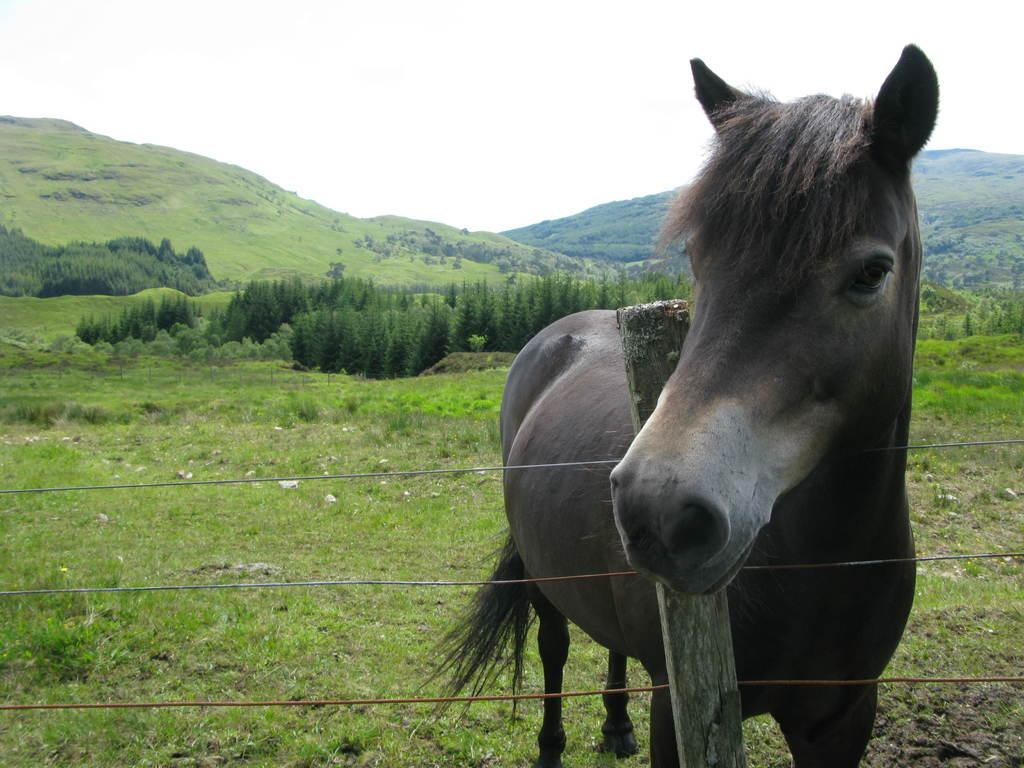What animal is present in the image? There is a horse in the image. Where is the horse located in relation to the fencing? The horse is standing in front of a fencing. What type of vegetation can be seen in the image? There are trees visible in the image. What type of landscape is visible in the background of the image? There is an open garden and mountains visible in the background of the image. What is visible at the top of the image? The sky is visible at the top of the image. What type of drum can be seen in the image? There is no drum present in the image. How many boxes are visible in the image? There are no boxes visible in the image. 